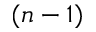<formula> <loc_0><loc_0><loc_500><loc_500>( n - 1 )</formula> 